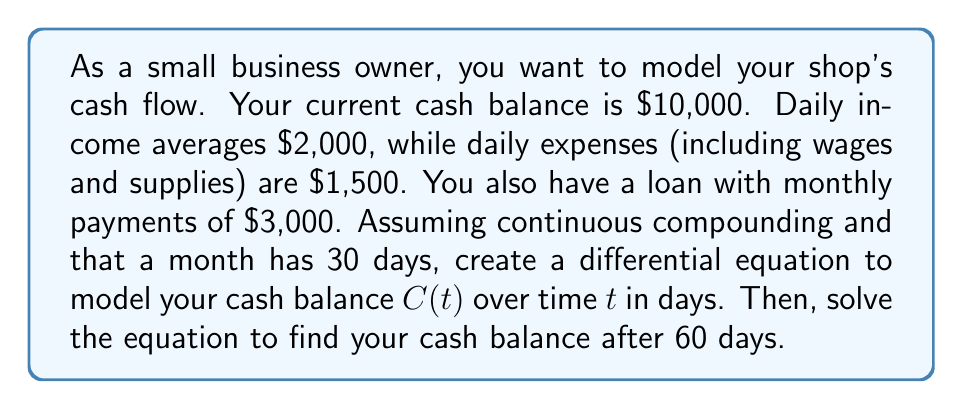Give your solution to this math problem. Let's approach this step-by-step:

1) First, we need to set up the differential equation. The rate of change of cash balance is given by:

   $$\frac{dC}{dt} = \text{Daily Income} - \text{Daily Expenses} - \text{Daily Loan Payment}$$

2) We know:
   - Daily Income = $2,000
   - Daily Expenses = $1,500
   - Monthly Loan Payment = $3,000
   - Daily Loan Payment = $3,000 / 30 = $100

3) Substituting these values:

   $$\frac{dC}{dt} = 2000 - 1500 - 100 = 400$$

4) This is a first-order linear differential equation. The general solution is:

   $$C(t) = 400t + K$$

   where $K$ is a constant of integration.

5) To find $K$, we use the initial condition. At $t=0$, $C(0) = 10000$:

   $$10000 = 400(0) + K$$
   $$K = 10000$$

6) Therefore, the particular solution is:

   $$C(t) = 400t + 10000$$

7) To find the cash balance after 60 days, we substitute $t=60$:

   $$C(60) = 400(60) + 10000 = 24000 + 10000 = 34000$$
Answer: The differential equation modeling the cash balance is:

$$\frac{dC}{dt} = 400$$

The solution to this equation, given the initial condition, is:

$$C(t) = 400t + 10000$$

After 60 days, the cash balance will be $34,000. 